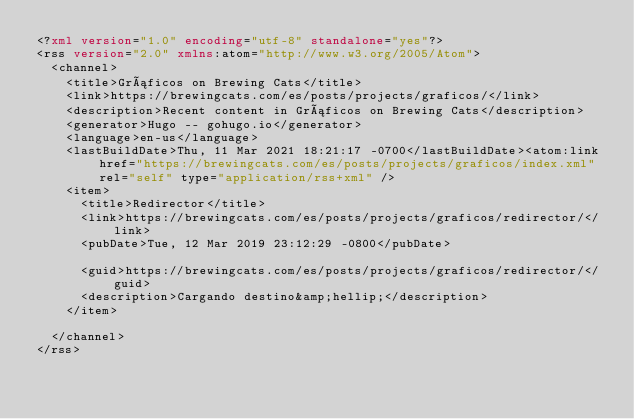<code> <loc_0><loc_0><loc_500><loc_500><_XML_><?xml version="1.0" encoding="utf-8" standalone="yes"?>
<rss version="2.0" xmlns:atom="http://www.w3.org/2005/Atom">
  <channel>
    <title>Gráficos on Brewing Cats</title>
    <link>https://brewingcats.com/es/posts/projects/graficos/</link>
    <description>Recent content in Gráficos on Brewing Cats</description>
    <generator>Hugo -- gohugo.io</generator>
    <language>en-us</language>
    <lastBuildDate>Thu, 11 Mar 2021 18:21:17 -0700</lastBuildDate><atom:link href="https://brewingcats.com/es/posts/projects/graficos/index.xml" rel="self" type="application/rss+xml" />
    <item>
      <title>Redirector</title>
      <link>https://brewingcats.com/es/posts/projects/graficos/redirector/</link>
      <pubDate>Tue, 12 Mar 2019 23:12:29 -0800</pubDate>
      
      <guid>https://brewingcats.com/es/posts/projects/graficos/redirector/</guid>
      <description>Cargando destino&amp;hellip;</description>
    </item>
    
  </channel>
</rss>
</code> 